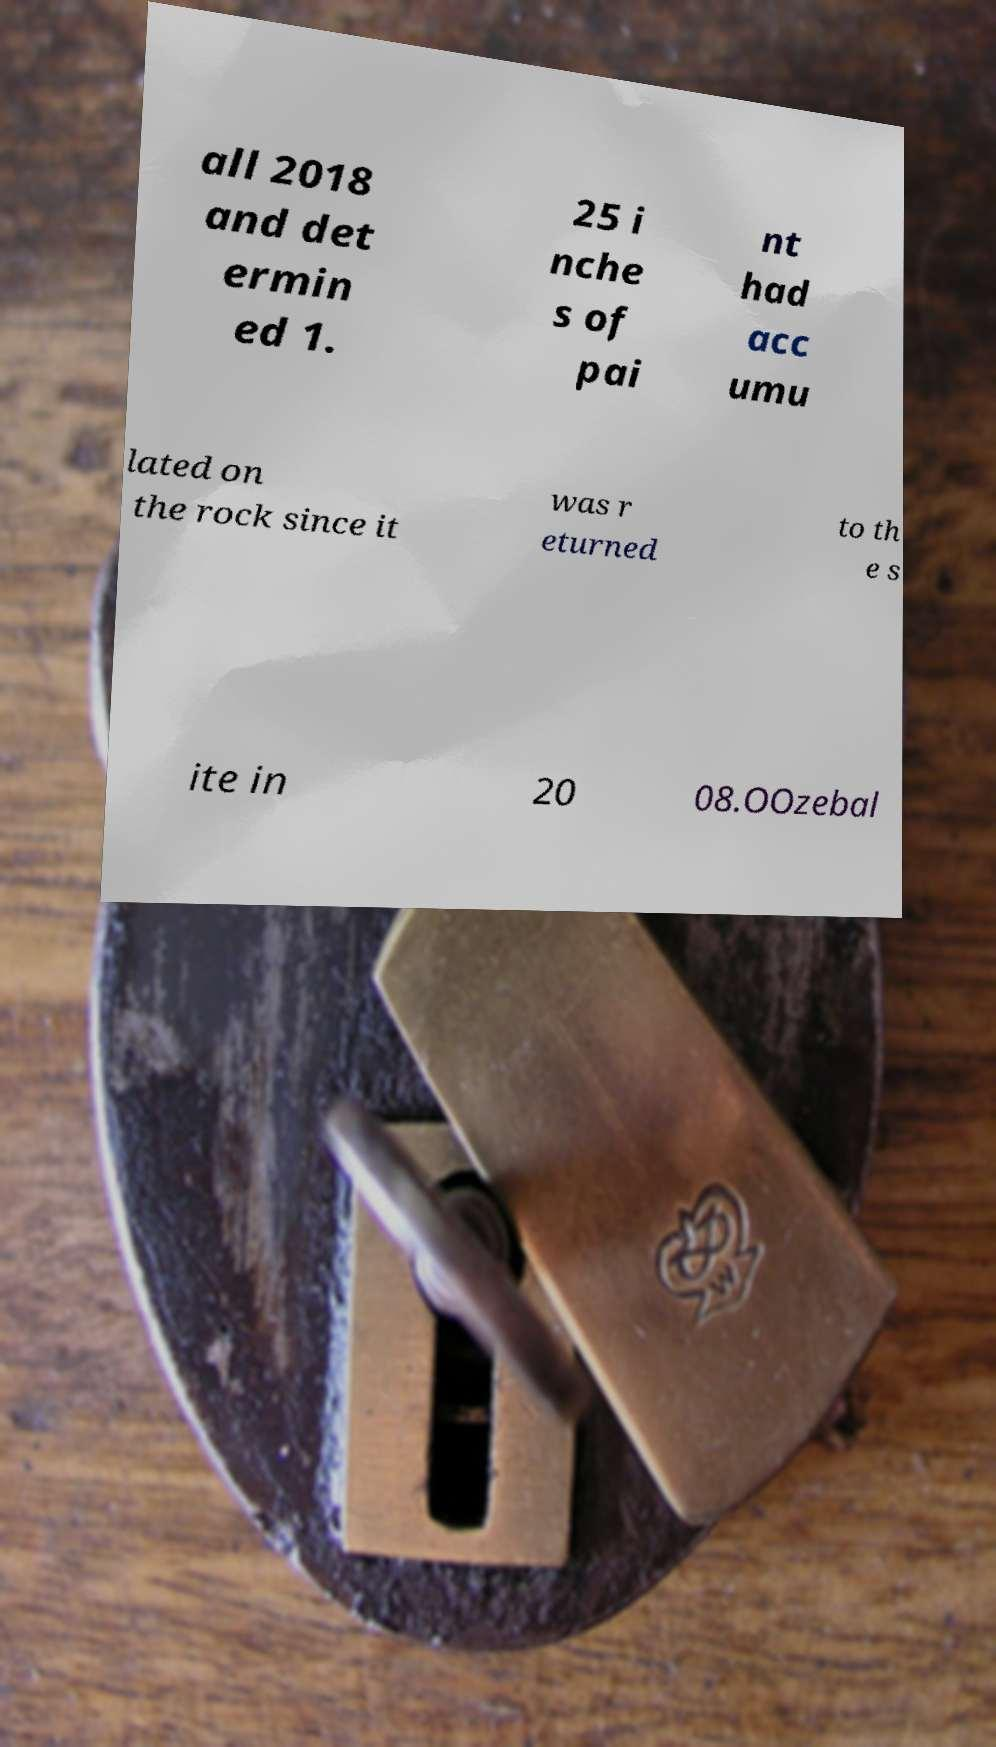There's text embedded in this image that I need extracted. Can you transcribe it verbatim? all 2018 and det ermin ed 1. 25 i nche s of pai nt had acc umu lated on the rock since it was r eturned to th e s ite in 20 08.OOzebal 